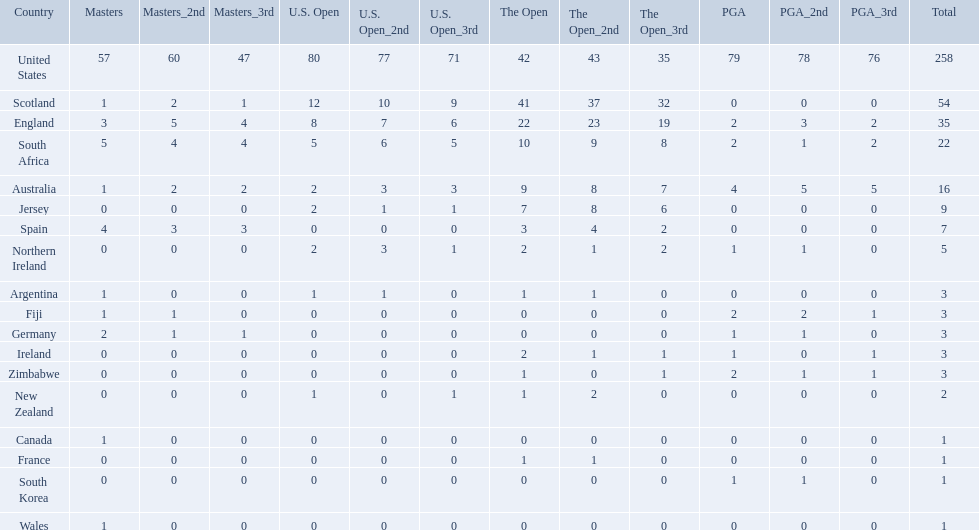What countries in the championship were from africa? South Africa, Zimbabwe. Which of these counteries had the least championship golfers Zimbabwe. 